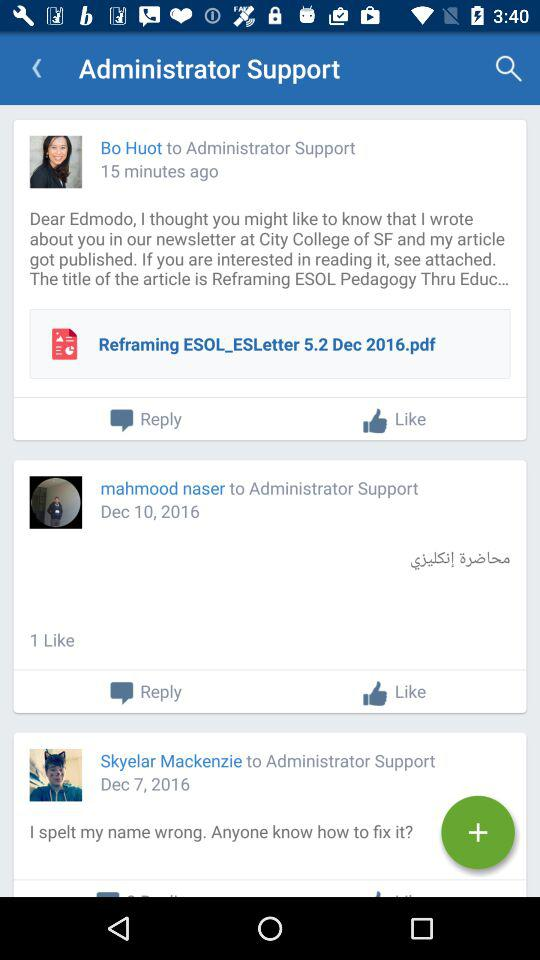How many messages have attachments?
Answer the question using a single word or phrase. 1 